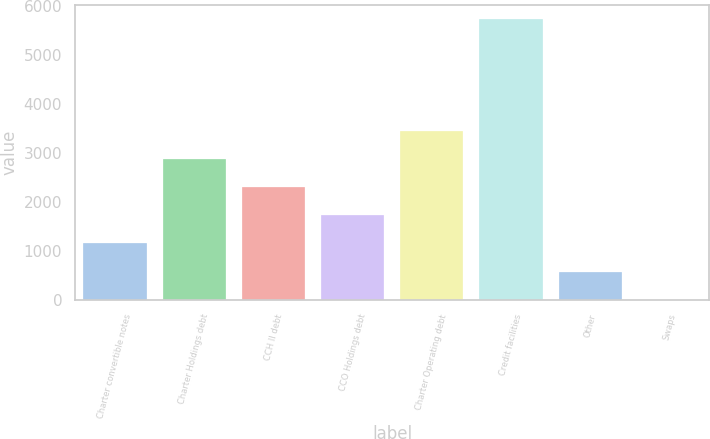Convert chart. <chart><loc_0><loc_0><loc_500><loc_500><bar_chart><fcel>Charter convertible notes<fcel>Charter Holdings debt<fcel>CCH II debt<fcel>CCO Holdings debt<fcel>Charter Operating debt<fcel>Credit facilities<fcel>Other<fcel>Swaps<nl><fcel>1149.4<fcel>2867.5<fcel>2294.8<fcel>1722.1<fcel>3440.2<fcel>5731<fcel>576.7<fcel>4<nl></chart> 